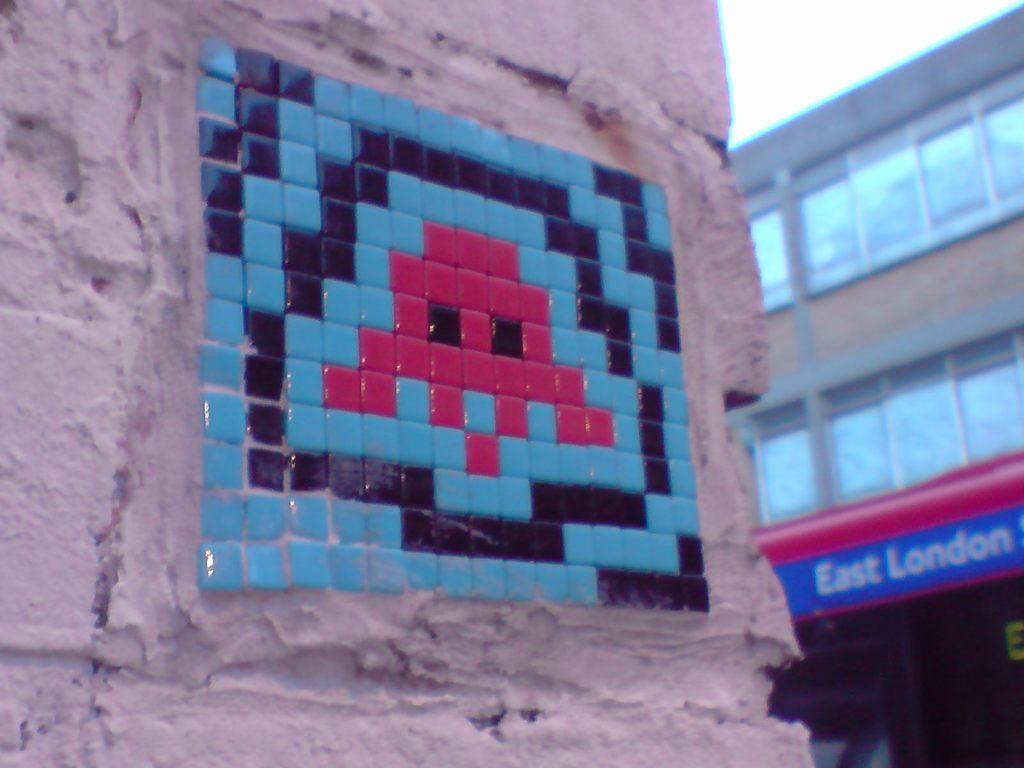What is depicted on the wall in the image? There is a wall with colorful stones in the image. What can be seen in the background of the image? There is a building and the sky visible in the background of the image. How many beads are scattered on the ground near the wall in the image? There are no beads present in the image; it only features a wall with colorful stones. Can you see any airplanes taking off or landing at the airport in the image? There is no airport or airplanes visible in the image; it only features a wall with colorful stones, a building in the background, and the sky. 